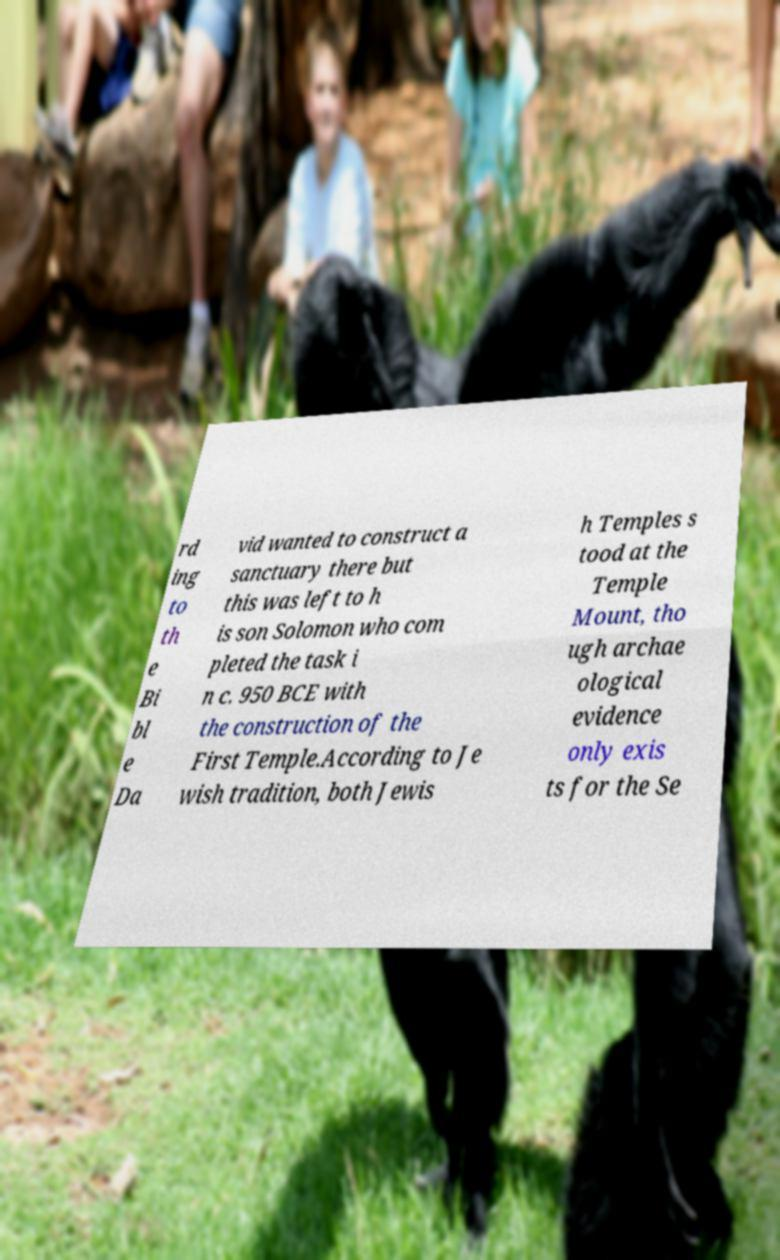Can you read and provide the text displayed in the image?This photo seems to have some interesting text. Can you extract and type it out for me? rd ing to th e Bi bl e Da vid wanted to construct a sanctuary there but this was left to h is son Solomon who com pleted the task i n c. 950 BCE with the construction of the First Temple.According to Je wish tradition, both Jewis h Temples s tood at the Temple Mount, tho ugh archae ological evidence only exis ts for the Se 